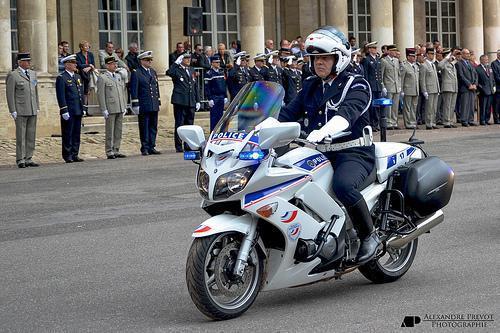How many tires are on the motorcycle?
Give a very brief answer. 2. How many men are on the motorcycle?
Give a very brief answer. 1. How many men are wearing a helmet?
Give a very brief answer. 1. 